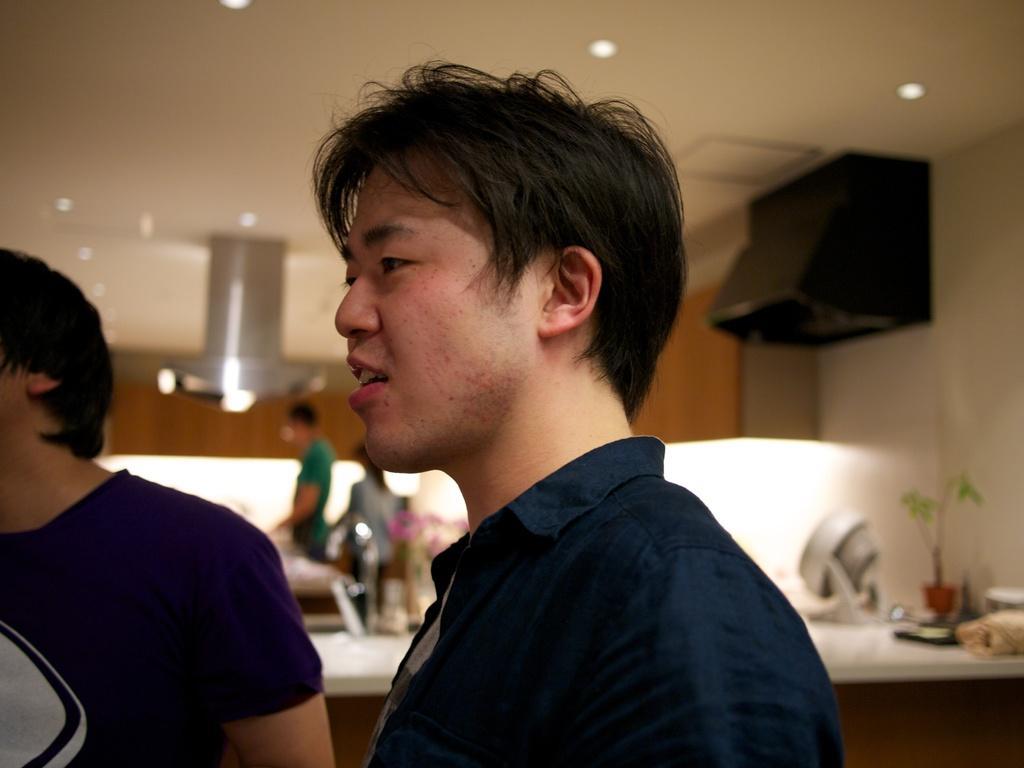Could you give a brief overview of what you see in this image? In this picture we can see a man is standing, and behind the man there are some people and a table and on the table there is a houseplant and other things. There are ceiling lights on the top. 